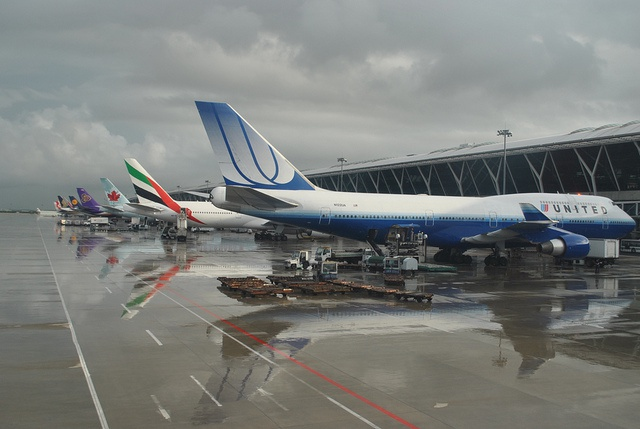Describe the objects in this image and their specific colors. I can see airplane in darkgray, lightgray, navy, and black tones, airplane in darkgray, gray, black, and lightgray tones, truck in darkgray, black, and gray tones, airplane in darkgray, gray, and brown tones, and truck in darkgray, gray, and black tones in this image. 